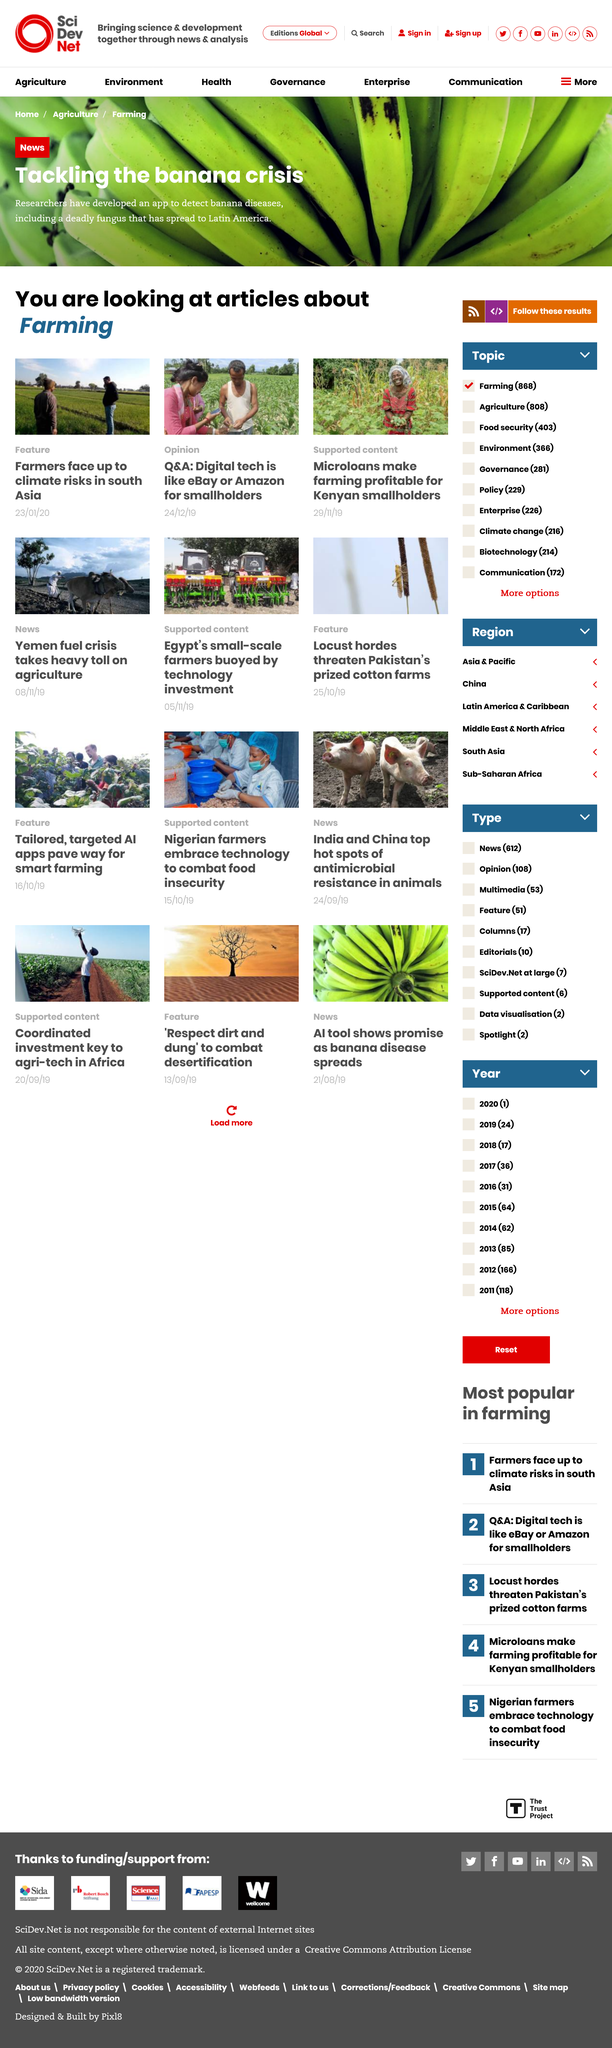List a handful of essential elements in this visual. South Asian farmers are facing the consequences of climate change, as highlighted in the feature article titled "Farmers face up to climate risks in south Asia". The articles are about farming. Researchers have developed an app to detect banana diseases in response to the banana crisis. 